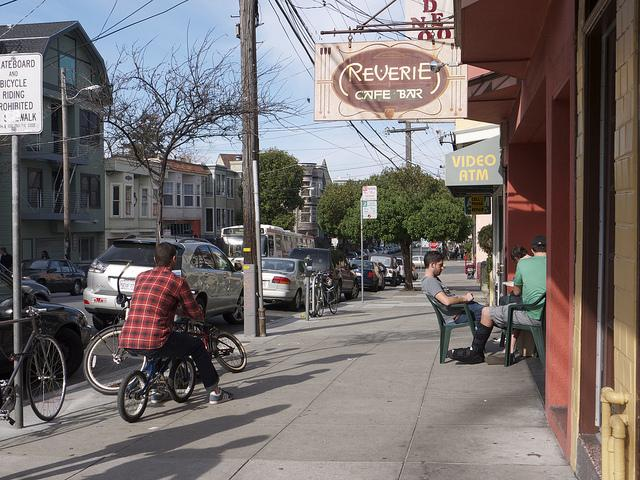What can the men do here? Please explain your reasoning. drink. The location seemingly in question is a cafe bar based on the sign. answer a is an activity that can be done at a cafe bar. 